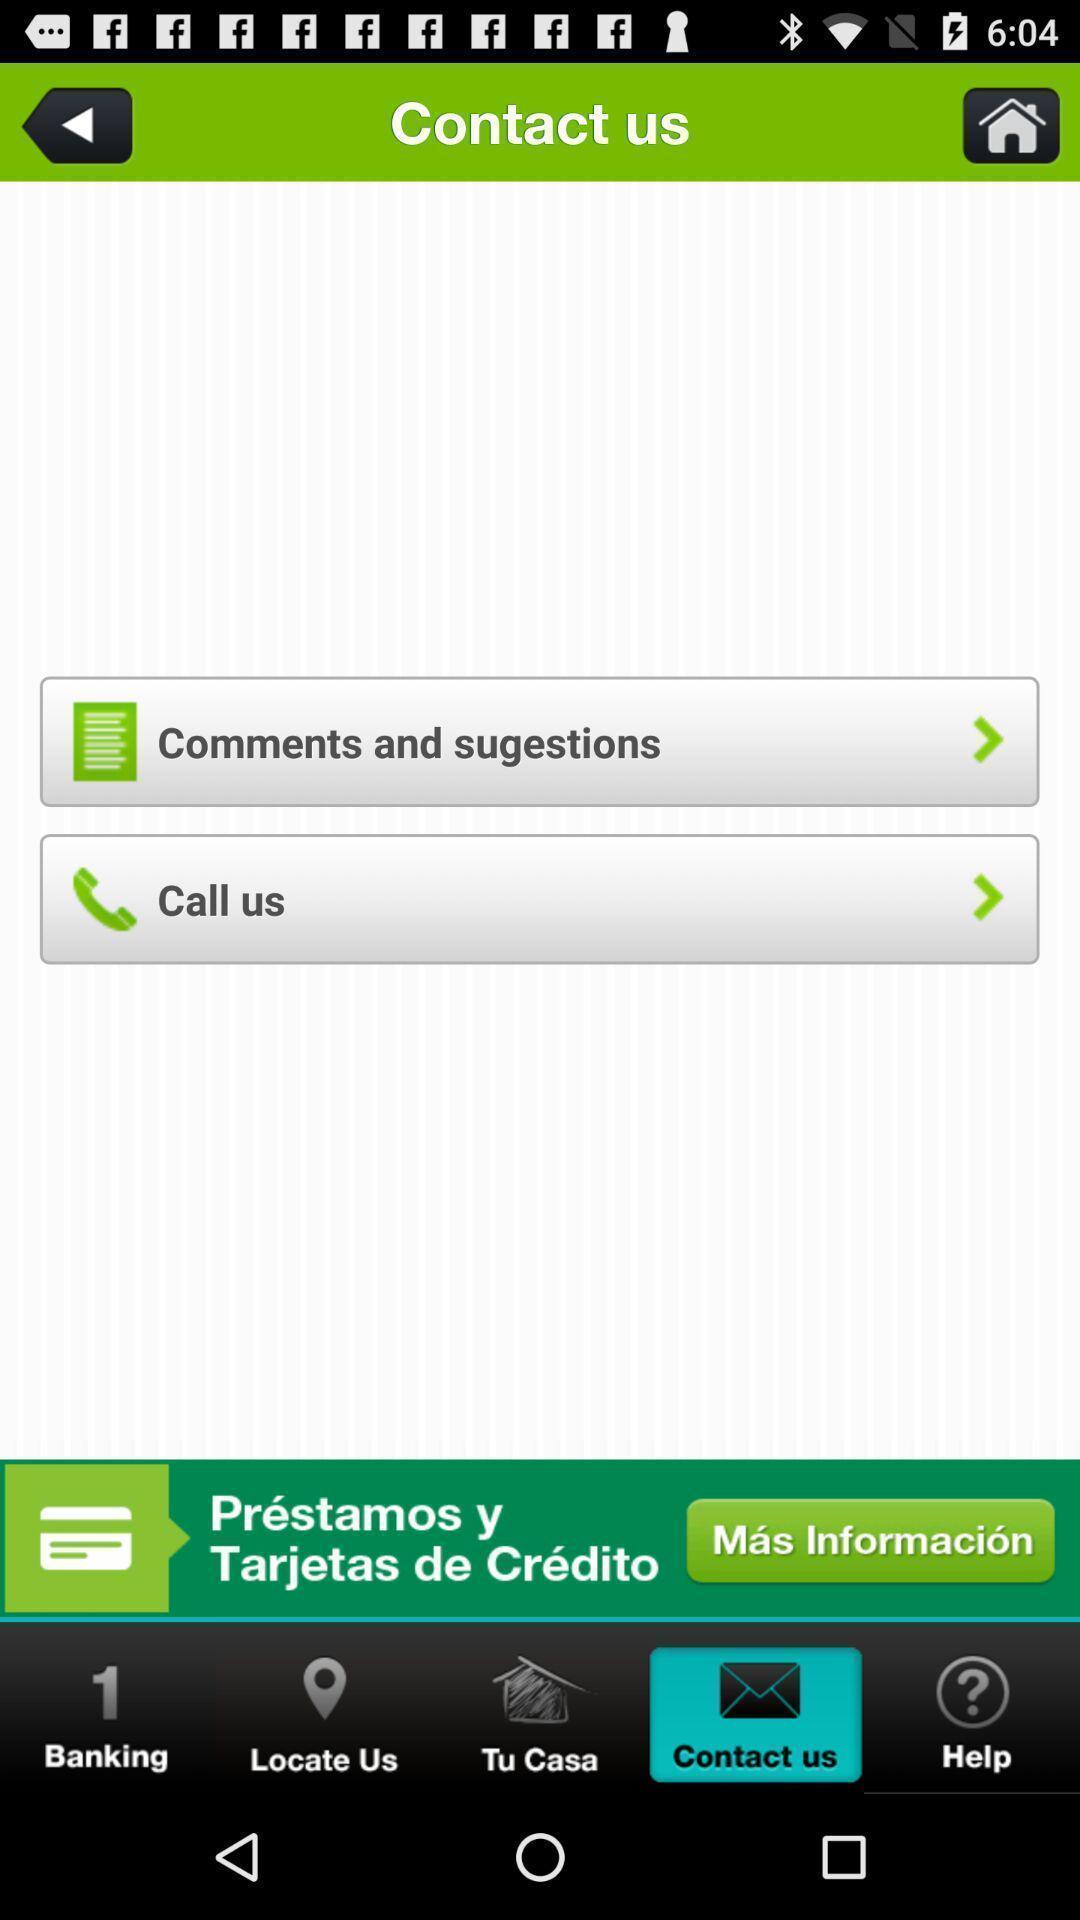Describe the visual elements of this screenshot. Screen displaying contact details with options. 